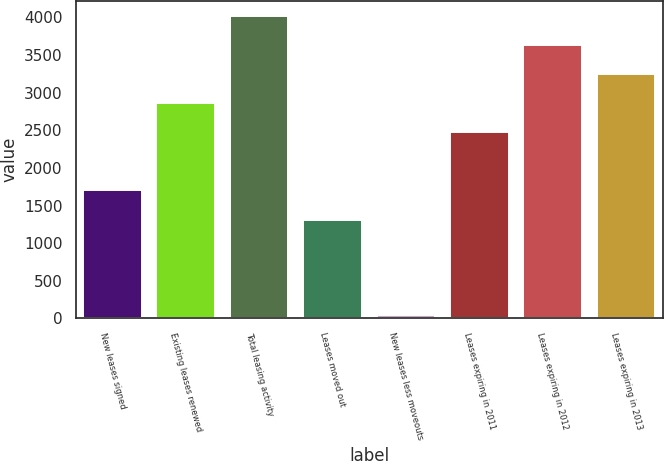Convert chart. <chart><loc_0><loc_0><loc_500><loc_500><bar_chart><fcel>New leases signed<fcel>Existing leases renewed<fcel>Total leasing activity<fcel>Leases moved out<fcel>New leases less moveouts<fcel>Leases expiring in 2011<fcel>Leases expiring in 2012<fcel>Leases expiring in 2013<nl><fcel>1700.1<fcel>2858.1<fcel>4019.4<fcel>1313<fcel>44<fcel>2471<fcel>3632.3<fcel>3245.2<nl></chart> 